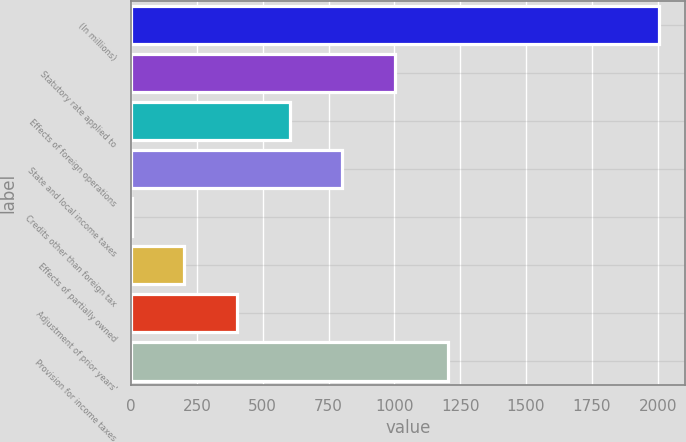Convert chart to OTSL. <chart><loc_0><loc_0><loc_500><loc_500><bar_chart><fcel>(In millions)<fcel>Statutory rate applied to<fcel>Effects of foreign operations<fcel>State and local income taxes<fcel>Credits other than foreign tax<fcel>Effects of partially owned<fcel>Adjustment of prior years'<fcel>Provision for income taxes<nl><fcel>2004<fcel>1003<fcel>602.6<fcel>802.8<fcel>2<fcel>202.2<fcel>402.4<fcel>1203.2<nl></chart> 